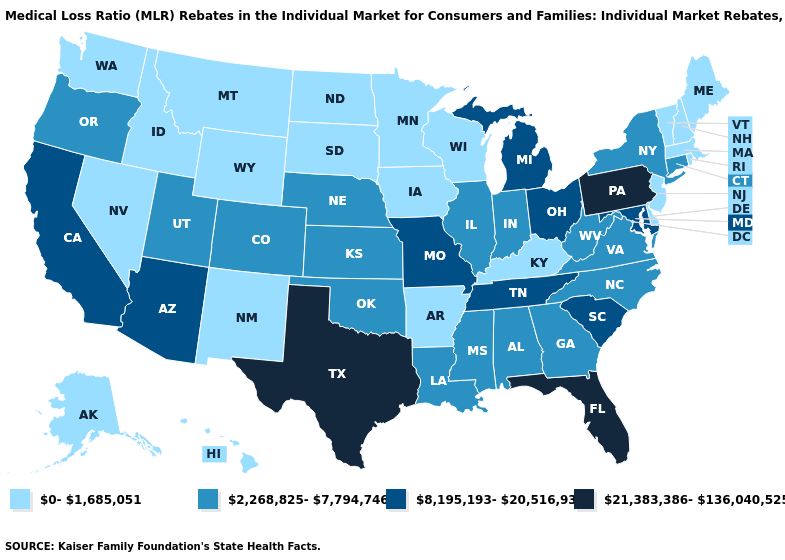What is the highest value in the Northeast ?
Answer briefly. 21,383,386-136,040,525. Does Ohio have the highest value in the MidWest?
Answer briefly. Yes. Does the map have missing data?
Give a very brief answer. No. What is the highest value in states that border Kentucky?
Answer briefly. 8,195,193-20,516,935. Does Delaware have the same value as Florida?
Give a very brief answer. No. Does Connecticut have the lowest value in the USA?
Be succinct. No. What is the lowest value in the USA?
Be succinct. 0-1,685,051. How many symbols are there in the legend?
Concise answer only. 4. Which states have the lowest value in the MidWest?
Keep it brief. Iowa, Minnesota, North Dakota, South Dakota, Wisconsin. What is the value of New Mexico?
Give a very brief answer. 0-1,685,051. Does New Hampshire have the lowest value in the Northeast?
Write a very short answer. Yes. Among the states that border Georgia , does South Carolina have the lowest value?
Concise answer only. No. What is the value of New Mexico?
Keep it brief. 0-1,685,051. Is the legend a continuous bar?
Quick response, please. No. What is the value of Mississippi?
Concise answer only. 2,268,825-7,794,746. 